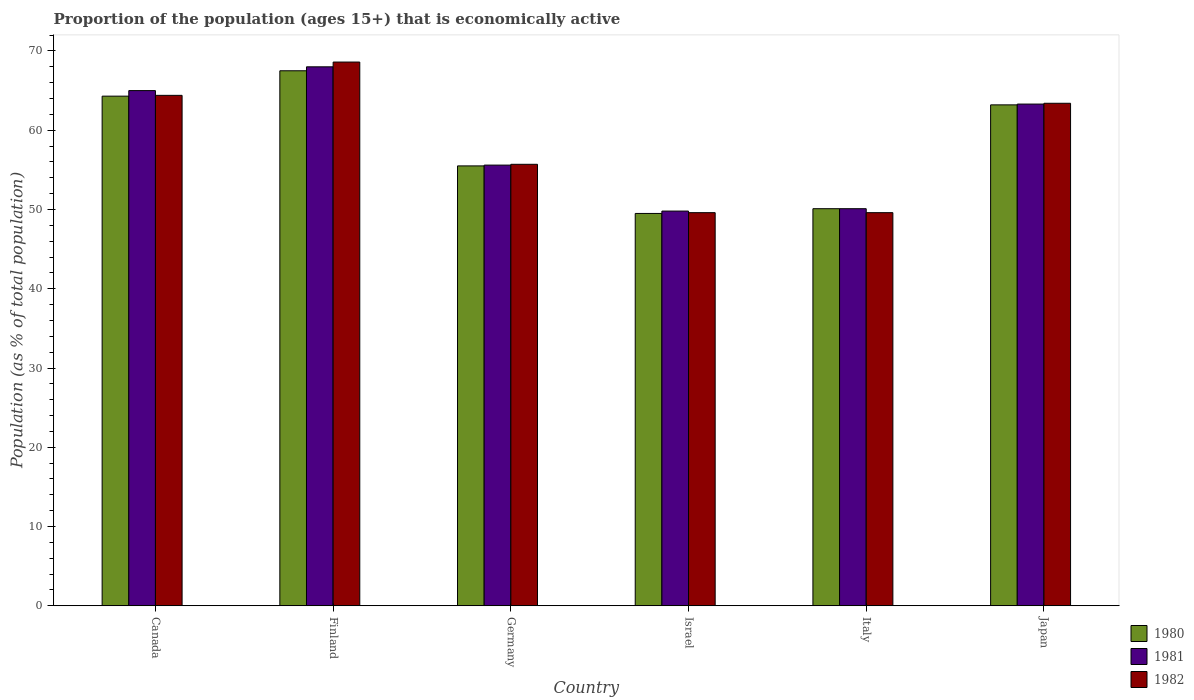How many different coloured bars are there?
Provide a succinct answer. 3. How many groups of bars are there?
Provide a short and direct response. 6. Are the number of bars per tick equal to the number of legend labels?
Your response must be concise. Yes. How many bars are there on the 4th tick from the left?
Ensure brevity in your answer.  3. What is the label of the 6th group of bars from the left?
Make the answer very short. Japan. What is the proportion of the population that is economically active in 1980 in Finland?
Your response must be concise. 67.5. Across all countries, what is the maximum proportion of the population that is economically active in 1981?
Provide a short and direct response. 68. Across all countries, what is the minimum proportion of the population that is economically active in 1981?
Give a very brief answer. 49.8. In which country was the proportion of the population that is economically active in 1981 maximum?
Provide a succinct answer. Finland. What is the total proportion of the population that is economically active in 1981 in the graph?
Offer a terse response. 351.8. What is the difference between the proportion of the population that is economically active in 1982 in Canada and that in Japan?
Make the answer very short. 1. What is the difference between the proportion of the population that is economically active in 1982 in Italy and the proportion of the population that is economically active in 1981 in Japan?
Your answer should be very brief. -13.7. What is the average proportion of the population that is economically active in 1981 per country?
Your answer should be very brief. 58.63. What is the difference between the proportion of the population that is economically active of/in 1982 and proportion of the population that is economically active of/in 1981 in Japan?
Make the answer very short. 0.1. In how many countries, is the proportion of the population that is economically active in 1982 greater than 42 %?
Offer a very short reply. 6. What is the ratio of the proportion of the population that is economically active in 1981 in Finland to that in Japan?
Provide a succinct answer. 1.07. What is the difference between the highest and the second highest proportion of the population that is economically active in 1980?
Your answer should be very brief. -3.2. What is the difference between the highest and the lowest proportion of the population that is economically active in 1980?
Your answer should be compact. 18. What does the 2nd bar from the left in Finland represents?
Make the answer very short. 1981. How many bars are there?
Give a very brief answer. 18. Are the values on the major ticks of Y-axis written in scientific E-notation?
Your answer should be very brief. No. Does the graph contain any zero values?
Provide a succinct answer. No. Does the graph contain grids?
Your response must be concise. No. How many legend labels are there?
Offer a terse response. 3. What is the title of the graph?
Your answer should be very brief. Proportion of the population (ages 15+) that is economically active. Does "1964" appear as one of the legend labels in the graph?
Your response must be concise. No. What is the label or title of the X-axis?
Ensure brevity in your answer.  Country. What is the label or title of the Y-axis?
Make the answer very short. Population (as % of total population). What is the Population (as % of total population) of 1980 in Canada?
Make the answer very short. 64.3. What is the Population (as % of total population) of 1981 in Canada?
Make the answer very short. 65. What is the Population (as % of total population) of 1982 in Canada?
Your answer should be compact. 64.4. What is the Population (as % of total population) of 1980 in Finland?
Provide a succinct answer. 67.5. What is the Population (as % of total population) in 1981 in Finland?
Your answer should be very brief. 68. What is the Population (as % of total population) of 1982 in Finland?
Your answer should be compact. 68.6. What is the Population (as % of total population) of 1980 in Germany?
Provide a short and direct response. 55.5. What is the Population (as % of total population) in 1981 in Germany?
Offer a terse response. 55.6. What is the Population (as % of total population) in 1982 in Germany?
Provide a succinct answer. 55.7. What is the Population (as % of total population) of 1980 in Israel?
Your answer should be compact. 49.5. What is the Population (as % of total population) of 1981 in Israel?
Give a very brief answer. 49.8. What is the Population (as % of total population) of 1982 in Israel?
Provide a succinct answer. 49.6. What is the Population (as % of total population) in 1980 in Italy?
Ensure brevity in your answer.  50.1. What is the Population (as % of total population) in 1981 in Italy?
Your answer should be compact. 50.1. What is the Population (as % of total population) in 1982 in Italy?
Ensure brevity in your answer.  49.6. What is the Population (as % of total population) in 1980 in Japan?
Your response must be concise. 63.2. What is the Population (as % of total population) of 1981 in Japan?
Keep it short and to the point. 63.3. What is the Population (as % of total population) of 1982 in Japan?
Your response must be concise. 63.4. Across all countries, what is the maximum Population (as % of total population) in 1980?
Provide a short and direct response. 67.5. Across all countries, what is the maximum Population (as % of total population) in 1981?
Ensure brevity in your answer.  68. Across all countries, what is the maximum Population (as % of total population) of 1982?
Give a very brief answer. 68.6. Across all countries, what is the minimum Population (as % of total population) in 1980?
Your answer should be very brief. 49.5. Across all countries, what is the minimum Population (as % of total population) in 1981?
Ensure brevity in your answer.  49.8. Across all countries, what is the minimum Population (as % of total population) of 1982?
Keep it short and to the point. 49.6. What is the total Population (as % of total population) of 1980 in the graph?
Provide a succinct answer. 350.1. What is the total Population (as % of total population) in 1981 in the graph?
Ensure brevity in your answer.  351.8. What is the total Population (as % of total population) in 1982 in the graph?
Give a very brief answer. 351.3. What is the difference between the Population (as % of total population) of 1982 in Canada and that in Finland?
Ensure brevity in your answer.  -4.2. What is the difference between the Population (as % of total population) in 1980 in Canada and that in Germany?
Give a very brief answer. 8.8. What is the difference between the Population (as % of total population) of 1982 in Canada and that in Germany?
Keep it short and to the point. 8.7. What is the difference between the Population (as % of total population) in 1980 in Canada and that in Israel?
Offer a terse response. 14.8. What is the difference between the Population (as % of total population) of 1980 in Canada and that in Japan?
Your answer should be compact. 1.1. What is the difference between the Population (as % of total population) in 1981 in Canada and that in Japan?
Offer a very short reply. 1.7. What is the difference between the Population (as % of total population) of 1980 in Finland and that in Germany?
Give a very brief answer. 12. What is the difference between the Population (as % of total population) of 1982 in Finland and that in Germany?
Ensure brevity in your answer.  12.9. What is the difference between the Population (as % of total population) in 1980 in Finland and that in Israel?
Keep it short and to the point. 18. What is the difference between the Population (as % of total population) in 1981 in Finland and that in Israel?
Offer a very short reply. 18.2. What is the difference between the Population (as % of total population) in 1982 in Finland and that in Israel?
Provide a succinct answer. 19. What is the difference between the Population (as % of total population) in 1980 in Finland and that in Italy?
Provide a short and direct response. 17.4. What is the difference between the Population (as % of total population) of 1981 in Finland and that in Italy?
Make the answer very short. 17.9. What is the difference between the Population (as % of total population) of 1982 in Finland and that in Italy?
Provide a short and direct response. 19. What is the difference between the Population (as % of total population) of 1981 in Finland and that in Japan?
Offer a very short reply. 4.7. What is the difference between the Population (as % of total population) of 1982 in Finland and that in Japan?
Make the answer very short. 5.2. What is the difference between the Population (as % of total population) of 1980 in Germany and that in Israel?
Ensure brevity in your answer.  6. What is the difference between the Population (as % of total population) of 1981 in Germany and that in Israel?
Your answer should be compact. 5.8. What is the difference between the Population (as % of total population) in 1982 in Germany and that in Israel?
Keep it short and to the point. 6.1. What is the difference between the Population (as % of total population) in 1982 in Germany and that in Italy?
Provide a short and direct response. 6.1. What is the difference between the Population (as % of total population) of 1980 in Germany and that in Japan?
Ensure brevity in your answer.  -7.7. What is the difference between the Population (as % of total population) of 1980 in Israel and that in Italy?
Offer a terse response. -0.6. What is the difference between the Population (as % of total population) in 1981 in Israel and that in Italy?
Offer a very short reply. -0.3. What is the difference between the Population (as % of total population) of 1982 in Israel and that in Italy?
Keep it short and to the point. 0. What is the difference between the Population (as % of total population) in 1980 in Israel and that in Japan?
Keep it short and to the point. -13.7. What is the difference between the Population (as % of total population) in 1980 in Canada and the Population (as % of total population) in 1982 in Finland?
Your answer should be very brief. -4.3. What is the difference between the Population (as % of total population) in 1981 in Canada and the Population (as % of total population) in 1982 in Finland?
Offer a very short reply. -3.6. What is the difference between the Population (as % of total population) of 1980 in Canada and the Population (as % of total population) of 1982 in Israel?
Your answer should be very brief. 14.7. What is the difference between the Population (as % of total population) of 1980 in Canada and the Population (as % of total population) of 1981 in Italy?
Provide a short and direct response. 14.2. What is the difference between the Population (as % of total population) in 1980 in Canada and the Population (as % of total population) in 1982 in Italy?
Ensure brevity in your answer.  14.7. What is the difference between the Population (as % of total population) in 1980 in Canada and the Population (as % of total population) in 1981 in Japan?
Keep it short and to the point. 1. What is the difference between the Population (as % of total population) of 1981 in Canada and the Population (as % of total population) of 1982 in Japan?
Your response must be concise. 1.6. What is the difference between the Population (as % of total population) of 1980 in Finland and the Population (as % of total population) of 1981 in Israel?
Offer a terse response. 17.7. What is the difference between the Population (as % of total population) in 1980 in Finland and the Population (as % of total population) in 1982 in Israel?
Make the answer very short. 17.9. What is the difference between the Population (as % of total population) of 1981 in Finland and the Population (as % of total population) of 1982 in Israel?
Ensure brevity in your answer.  18.4. What is the difference between the Population (as % of total population) in 1981 in Finland and the Population (as % of total population) in 1982 in Italy?
Your answer should be very brief. 18.4. What is the difference between the Population (as % of total population) of 1980 in Finland and the Population (as % of total population) of 1981 in Japan?
Ensure brevity in your answer.  4.2. What is the difference between the Population (as % of total population) of 1980 in Germany and the Population (as % of total population) of 1982 in Israel?
Keep it short and to the point. 5.9. What is the difference between the Population (as % of total population) of 1980 in Germany and the Population (as % of total population) of 1981 in Japan?
Give a very brief answer. -7.8. What is the difference between the Population (as % of total population) in 1981 in Germany and the Population (as % of total population) in 1982 in Japan?
Provide a succinct answer. -7.8. What is the difference between the Population (as % of total population) of 1980 in Israel and the Population (as % of total population) of 1982 in Italy?
Provide a succinct answer. -0.1. What is the difference between the Population (as % of total population) of 1981 in Israel and the Population (as % of total population) of 1982 in Italy?
Provide a succinct answer. 0.2. What is the difference between the Population (as % of total population) of 1980 in Israel and the Population (as % of total population) of 1981 in Japan?
Provide a short and direct response. -13.8. What is the difference between the Population (as % of total population) of 1980 in Italy and the Population (as % of total population) of 1982 in Japan?
Provide a short and direct response. -13.3. What is the difference between the Population (as % of total population) of 1981 in Italy and the Population (as % of total population) of 1982 in Japan?
Offer a very short reply. -13.3. What is the average Population (as % of total population) of 1980 per country?
Offer a terse response. 58.35. What is the average Population (as % of total population) of 1981 per country?
Provide a succinct answer. 58.63. What is the average Population (as % of total population) of 1982 per country?
Keep it short and to the point. 58.55. What is the difference between the Population (as % of total population) in 1980 and Population (as % of total population) in 1982 in Canada?
Your answer should be compact. -0.1. What is the difference between the Population (as % of total population) in 1981 and Population (as % of total population) in 1982 in Canada?
Your answer should be very brief. 0.6. What is the difference between the Population (as % of total population) in 1980 and Population (as % of total population) in 1981 in Germany?
Provide a short and direct response. -0.1. What is the difference between the Population (as % of total population) in 1981 and Population (as % of total population) in 1982 in Israel?
Offer a terse response. 0.2. What is the difference between the Population (as % of total population) in 1980 and Population (as % of total population) in 1982 in Italy?
Your answer should be compact. 0.5. What is the difference between the Population (as % of total population) in 1980 and Population (as % of total population) in 1981 in Japan?
Make the answer very short. -0.1. What is the difference between the Population (as % of total population) in 1980 and Population (as % of total population) in 1982 in Japan?
Offer a very short reply. -0.2. What is the difference between the Population (as % of total population) of 1981 and Population (as % of total population) of 1982 in Japan?
Ensure brevity in your answer.  -0.1. What is the ratio of the Population (as % of total population) in 1980 in Canada to that in Finland?
Your response must be concise. 0.95. What is the ratio of the Population (as % of total population) of 1981 in Canada to that in Finland?
Make the answer very short. 0.96. What is the ratio of the Population (as % of total population) of 1982 in Canada to that in Finland?
Provide a succinct answer. 0.94. What is the ratio of the Population (as % of total population) in 1980 in Canada to that in Germany?
Your answer should be compact. 1.16. What is the ratio of the Population (as % of total population) in 1981 in Canada to that in Germany?
Provide a succinct answer. 1.17. What is the ratio of the Population (as % of total population) in 1982 in Canada to that in Germany?
Provide a succinct answer. 1.16. What is the ratio of the Population (as % of total population) in 1980 in Canada to that in Israel?
Offer a terse response. 1.3. What is the ratio of the Population (as % of total population) in 1981 in Canada to that in Israel?
Your answer should be very brief. 1.31. What is the ratio of the Population (as % of total population) of 1982 in Canada to that in Israel?
Ensure brevity in your answer.  1.3. What is the ratio of the Population (as % of total population) in 1980 in Canada to that in Italy?
Keep it short and to the point. 1.28. What is the ratio of the Population (as % of total population) of 1981 in Canada to that in Italy?
Offer a terse response. 1.3. What is the ratio of the Population (as % of total population) of 1982 in Canada to that in Italy?
Provide a succinct answer. 1.3. What is the ratio of the Population (as % of total population) of 1980 in Canada to that in Japan?
Your response must be concise. 1.02. What is the ratio of the Population (as % of total population) in 1981 in Canada to that in Japan?
Your response must be concise. 1.03. What is the ratio of the Population (as % of total population) of 1982 in Canada to that in Japan?
Make the answer very short. 1.02. What is the ratio of the Population (as % of total population) in 1980 in Finland to that in Germany?
Make the answer very short. 1.22. What is the ratio of the Population (as % of total population) in 1981 in Finland to that in Germany?
Offer a terse response. 1.22. What is the ratio of the Population (as % of total population) of 1982 in Finland to that in Germany?
Give a very brief answer. 1.23. What is the ratio of the Population (as % of total population) of 1980 in Finland to that in Israel?
Offer a terse response. 1.36. What is the ratio of the Population (as % of total population) of 1981 in Finland to that in Israel?
Give a very brief answer. 1.37. What is the ratio of the Population (as % of total population) of 1982 in Finland to that in Israel?
Make the answer very short. 1.38. What is the ratio of the Population (as % of total population) in 1980 in Finland to that in Italy?
Offer a very short reply. 1.35. What is the ratio of the Population (as % of total population) in 1981 in Finland to that in Italy?
Provide a short and direct response. 1.36. What is the ratio of the Population (as % of total population) in 1982 in Finland to that in Italy?
Your response must be concise. 1.38. What is the ratio of the Population (as % of total population) in 1980 in Finland to that in Japan?
Give a very brief answer. 1.07. What is the ratio of the Population (as % of total population) of 1981 in Finland to that in Japan?
Provide a succinct answer. 1.07. What is the ratio of the Population (as % of total population) in 1982 in Finland to that in Japan?
Give a very brief answer. 1.08. What is the ratio of the Population (as % of total population) of 1980 in Germany to that in Israel?
Your answer should be compact. 1.12. What is the ratio of the Population (as % of total population) in 1981 in Germany to that in Israel?
Keep it short and to the point. 1.12. What is the ratio of the Population (as % of total population) of 1982 in Germany to that in Israel?
Keep it short and to the point. 1.12. What is the ratio of the Population (as % of total population) in 1980 in Germany to that in Italy?
Your answer should be compact. 1.11. What is the ratio of the Population (as % of total population) of 1981 in Germany to that in Italy?
Offer a very short reply. 1.11. What is the ratio of the Population (as % of total population) in 1982 in Germany to that in Italy?
Offer a terse response. 1.12. What is the ratio of the Population (as % of total population) in 1980 in Germany to that in Japan?
Ensure brevity in your answer.  0.88. What is the ratio of the Population (as % of total population) of 1981 in Germany to that in Japan?
Offer a terse response. 0.88. What is the ratio of the Population (as % of total population) in 1982 in Germany to that in Japan?
Ensure brevity in your answer.  0.88. What is the ratio of the Population (as % of total population) in 1980 in Israel to that in Italy?
Provide a succinct answer. 0.99. What is the ratio of the Population (as % of total population) in 1980 in Israel to that in Japan?
Offer a very short reply. 0.78. What is the ratio of the Population (as % of total population) in 1981 in Israel to that in Japan?
Your answer should be compact. 0.79. What is the ratio of the Population (as % of total population) in 1982 in Israel to that in Japan?
Your answer should be compact. 0.78. What is the ratio of the Population (as % of total population) of 1980 in Italy to that in Japan?
Make the answer very short. 0.79. What is the ratio of the Population (as % of total population) of 1981 in Italy to that in Japan?
Offer a terse response. 0.79. What is the ratio of the Population (as % of total population) in 1982 in Italy to that in Japan?
Offer a terse response. 0.78. What is the difference between the highest and the second highest Population (as % of total population) in 1980?
Provide a short and direct response. 3.2. What is the difference between the highest and the second highest Population (as % of total population) of 1982?
Your answer should be very brief. 4.2. What is the difference between the highest and the lowest Population (as % of total population) of 1980?
Provide a short and direct response. 18. What is the difference between the highest and the lowest Population (as % of total population) in 1982?
Offer a terse response. 19. 